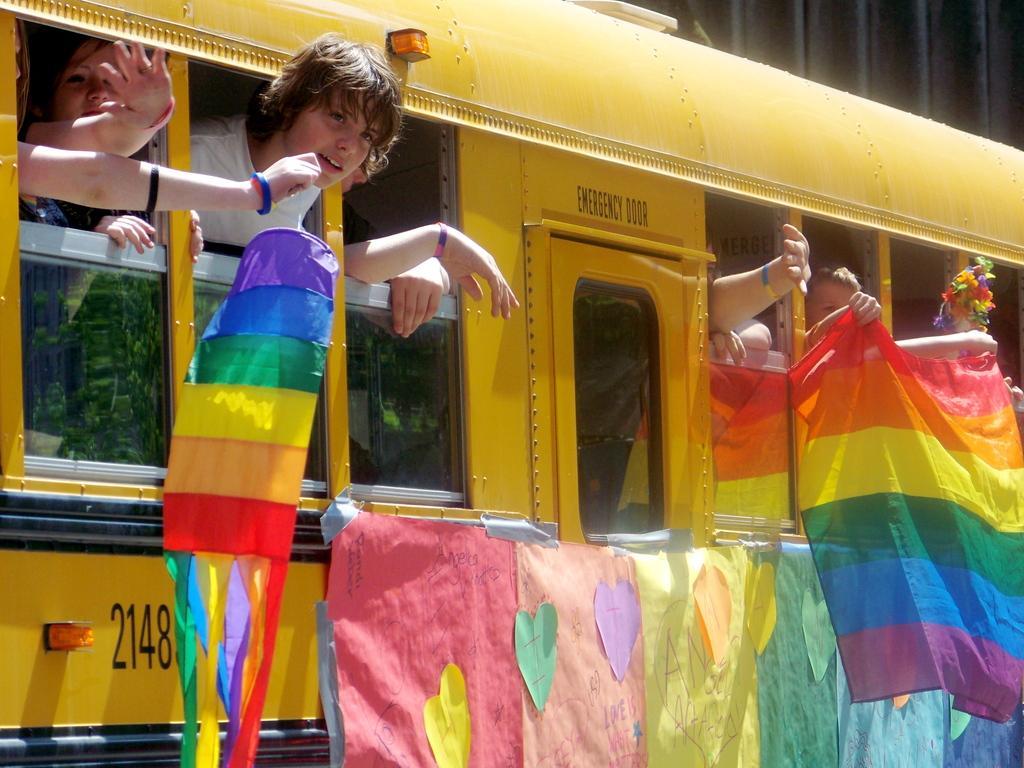Please provide a concise description of this image. In this image i can see a bus which is in yellow color sticking their heads out of window and playing with some objects. 